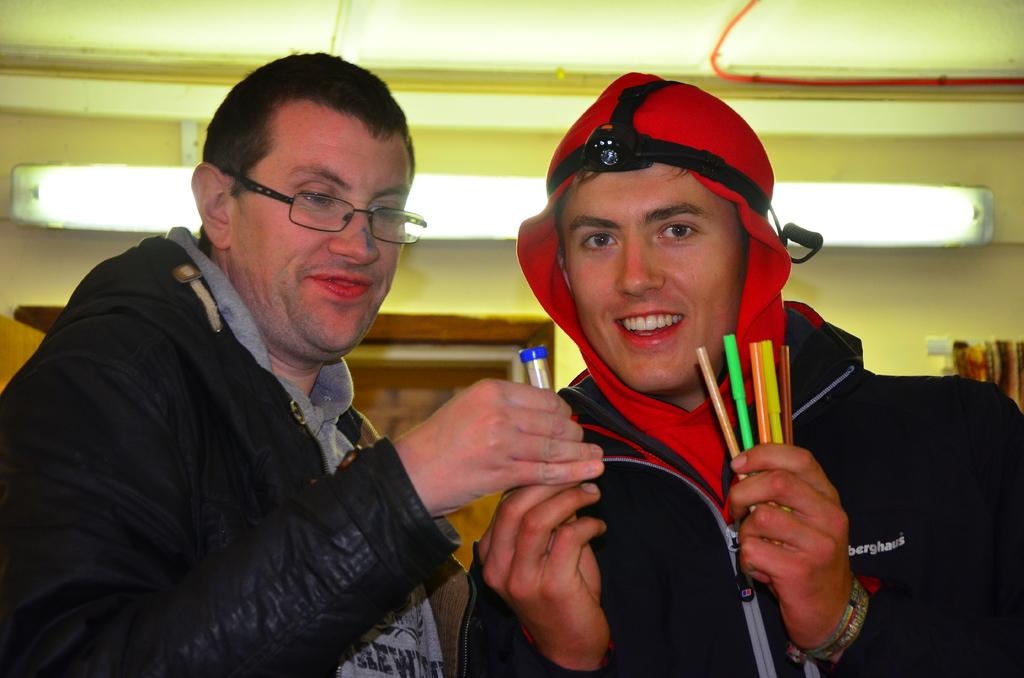How many people are in the image? There are two persons in the image. What are the persons holding in the image? The persons are holding objects. What can be seen in the background of the image? There is a light and a wall in the background of the image. What type of wristwatch can be seen on the persons' wrists in the image? There is no wristwatch visible on the persons' wrists in the image. What type of cub is depicted on the objects the persons are holding? There is no cub depicted on the objects the persons are holding in the image. 